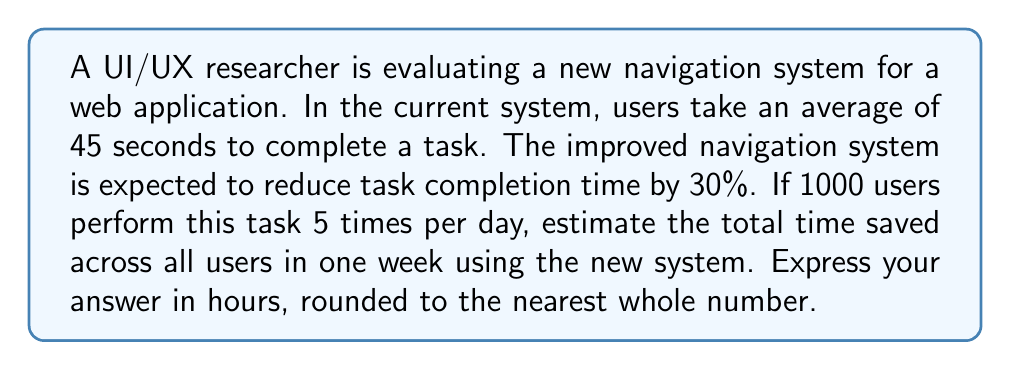Can you answer this question? Let's break this problem down step-by-step:

1. Calculate the time saved per task:
   * Current time per task = 45 seconds
   * Reduction = 30% = 0.30
   * Time saved per task = $45 \times 0.30 = 13.5$ seconds

2. Calculate the time saved per user per day:
   * Tasks per day = 5
   * Time saved per user per day = $13.5 \times 5 = 67.5$ seconds

3. Calculate the time saved for all users per day:
   * Number of users = 1000
   * Time saved per day = $67.5 \times 1000 = 67,500$ seconds

4. Calculate the time saved in one week:
   * Days in a week = 7
   * Time saved in one week = $67,500 \times 7 = 472,500$ seconds

5. Convert seconds to hours:
   * 1 hour = 3600 seconds
   * Time saved in hours = $\frac{472,500}{3600} = 131.25$ hours

6. Round to the nearest whole number:
   * 131.25 rounds to 131 hours
Answer: 131 hours 